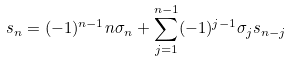Convert formula to latex. <formula><loc_0><loc_0><loc_500><loc_500>s _ { n } & = ( - 1 ) ^ { n - 1 } n \sigma _ { n } + \sum _ { j = 1 } ^ { n - 1 } ( - 1 ) ^ { j - 1 } \sigma _ { j } s _ { n - j }</formula> 